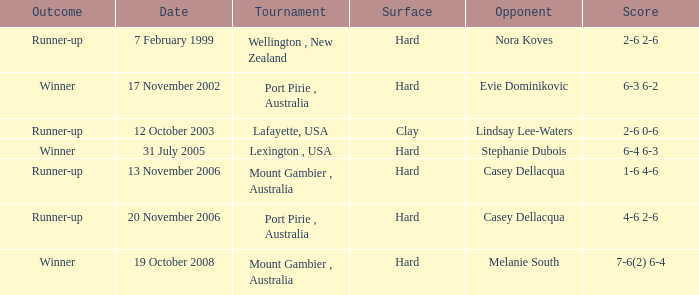What was the result on november 13, 2006? Runner-up. 